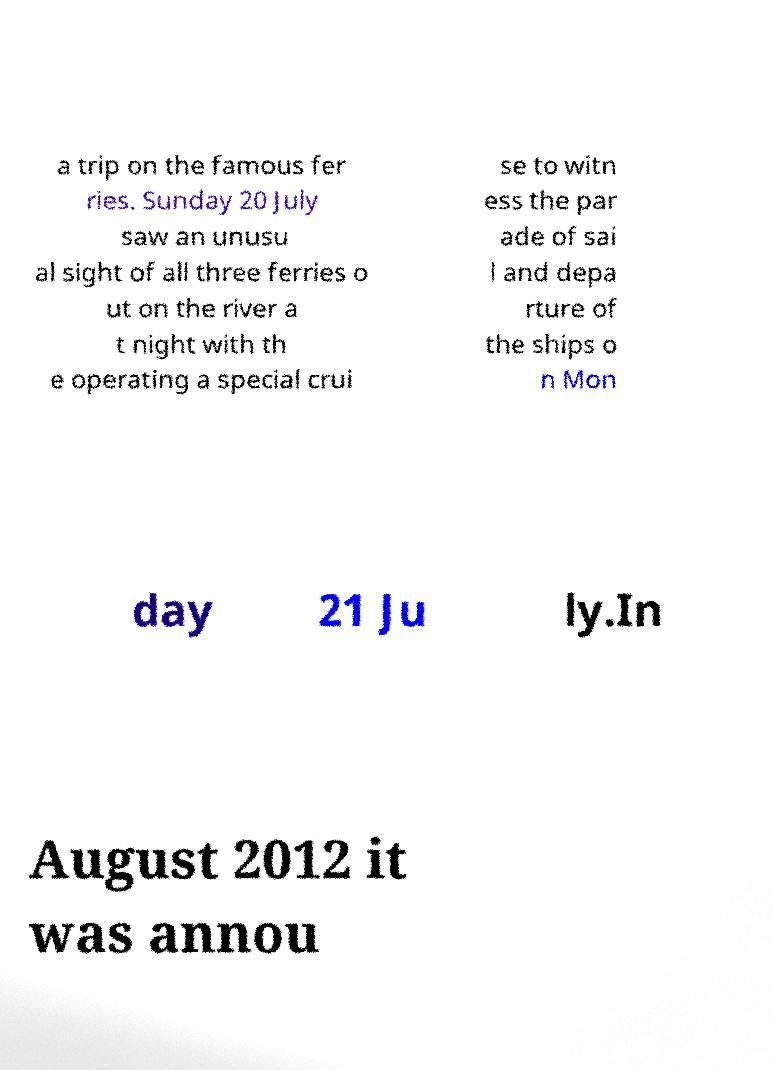I need the written content from this picture converted into text. Can you do that? a trip on the famous fer ries. Sunday 20 July saw an unusu al sight of all three ferries o ut on the river a t night with th e operating a special crui se to witn ess the par ade of sai l and depa rture of the ships o n Mon day 21 Ju ly.In August 2012 it was annou 